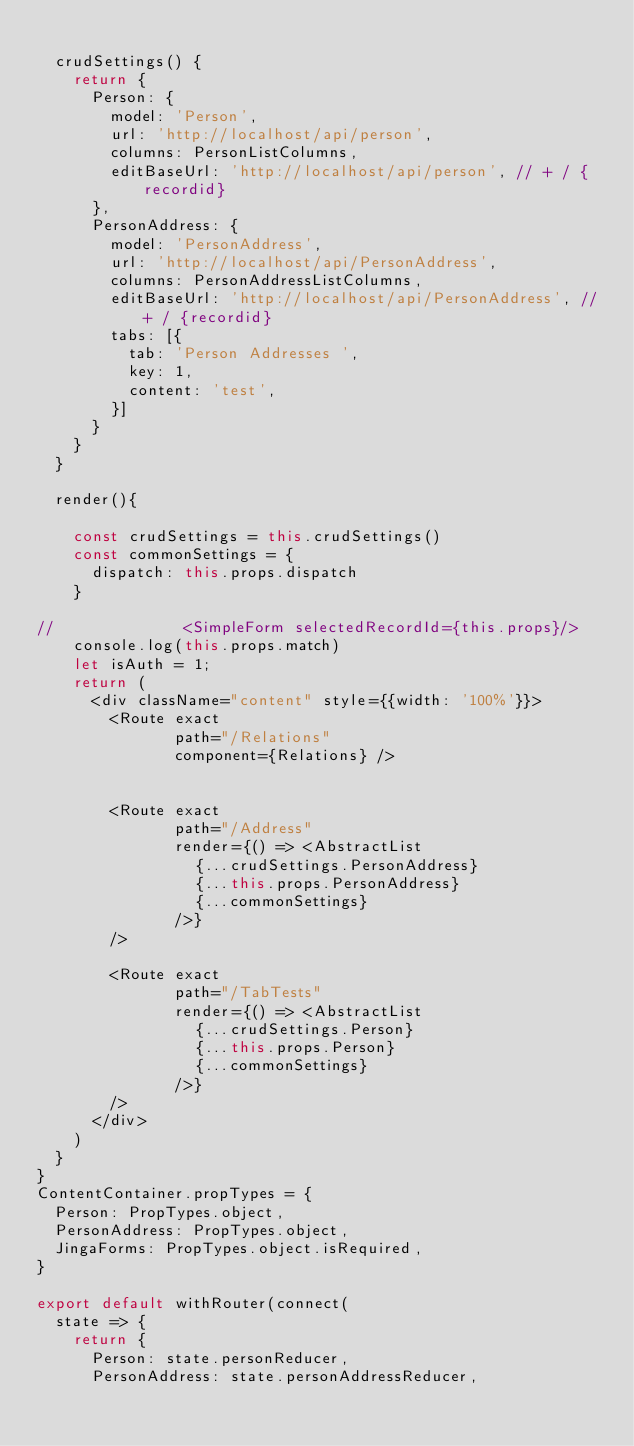Convert code to text. <code><loc_0><loc_0><loc_500><loc_500><_JavaScript_>
  crudSettings() {
    return {
      Person: {
        model: 'Person',
        url: 'http://localhost/api/person',
        columns: PersonListColumns,
        editBaseUrl: 'http://localhost/api/person', // + / {recordid}
      },
      PersonAddress: {
        model: 'PersonAddress',
        url: 'http://localhost/api/PersonAddress',
        columns: PersonAddressListColumns,
        editBaseUrl: 'http://localhost/api/PersonAddress', // + / {recordid}
        tabs: [{
          tab: 'Person Addresses ',
          key: 1,
	        content: 'test',
        }]
      }
    }
  }

  render(){

    const crudSettings = this.crudSettings()
    const commonSettings = {
      dispatch: this.props.dispatch
    }

//              <SimpleForm selectedRecordId={this.props}/>
    console.log(this.props.match)
    let isAuth = 1;
    return (
      <div className="content" style={{width: '100%'}}>
        <Route exact
               path="/Relations"
               component={Relations} />


        <Route exact
               path="/Address"
               render={() => <AbstractList
                 {...crudSettings.PersonAddress}
                 {...this.props.PersonAddress}
                 {...commonSettings}
               />}
        />

        <Route exact
               path="/TabTests"
               render={() => <AbstractList
                 {...crudSettings.Person}
                 {...this.props.Person}
                 {...commonSettings}
               />}
        />
      </div>
    )
  }
}
ContentContainer.propTypes = {
  Person: PropTypes.object,
  PersonAddress: PropTypes.object,
  JingaForms: PropTypes.object.isRequired,
}

export default withRouter(connect(
  state => {
    return {
      Person: state.personReducer,
      PersonAddress: state.personAddressReducer,</code> 